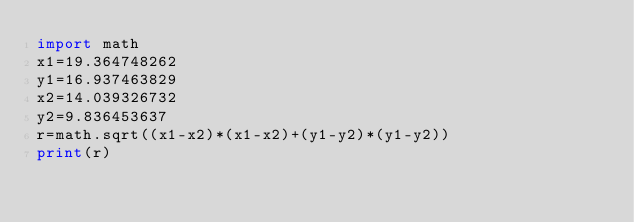<code> <loc_0><loc_0><loc_500><loc_500><_Python_>import math
x1=19.364748262
y1=16.937463829
x2=14.039326732
y2=9.836453637
r=math.sqrt((x1-x2)*(x1-x2)+(y1-y2)*(y1-y2))
print(r)</code> 